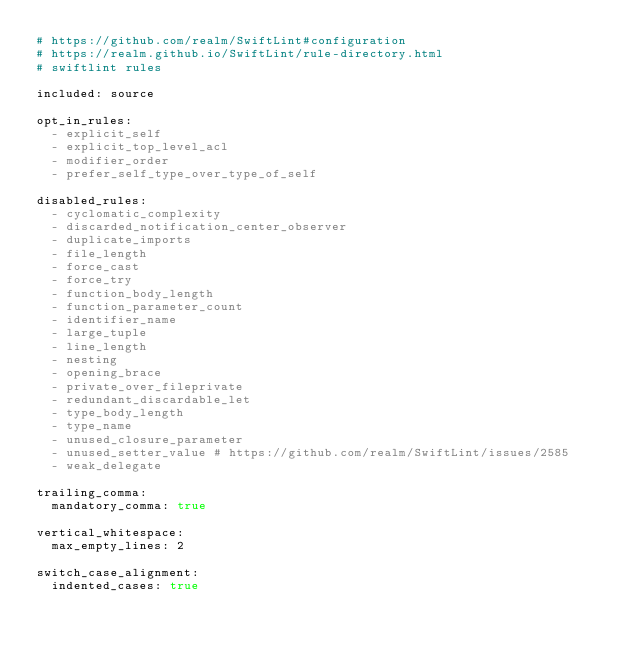Convert code to text. <code><loc_0><loc_0><loc_500><loc_500><_YAML_># https://github.com/realm/SwiftLint#configuration
# https://realm.github.io/SwiftLint/rule-directory.html
# swiftlint rules

included: source

opt_in_rules:
  - explicit_self
  - explicit_top_level_acl
  - modifier_order
  - prefer_self_type_over_type_of_self

disabled_rules:
  - cyclomatic_complexity
  - discarded_notification_center_observer
  - duplicate_imports
  - file_length
  - force_cast
  - force_try
  - function_body_length
  - function_parameter_count
  - identifier_name
  - large_tuple
  - line_length
  - nesting
  - opening_brace
  - private_over_fileprivate
  - redundant_discardable_let
  - type_body_length
  - type_name
  - unused_closure_parameter
  - unused_setter_value # https://github.com/realm/SwiftLint/issues/2585
  - weak_delegate

trailing_comma:
  mandatory_comma: true

vertical_whitespace:
  max_empty_lines: 2

switch_case_alignment:
  indented_cases: true
</code> 